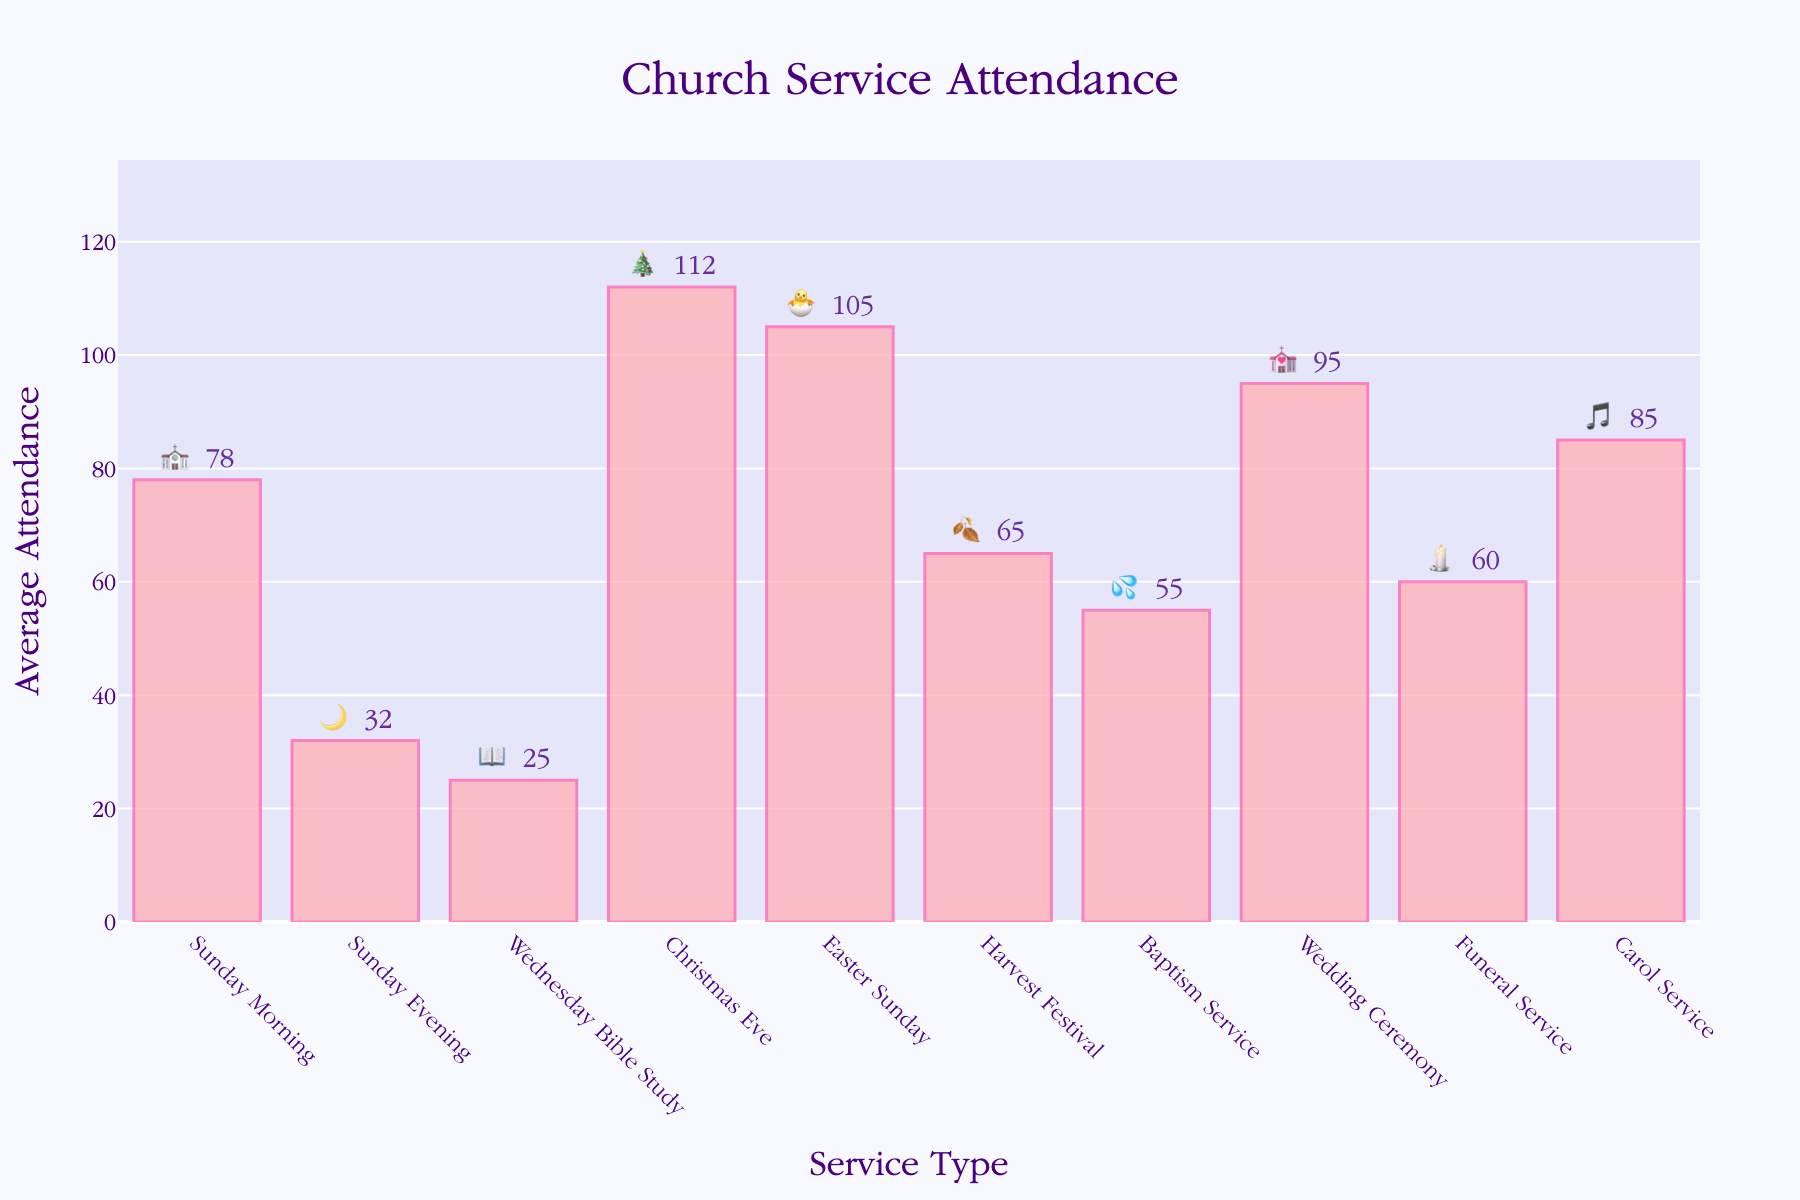What's the title of the figure? The title of the figure is written at the top center of the chart and is usually in a larger font size than other text.
Answer: Church Service Attendance Which service had the highest average attendance? The bar with the highest length represents the service with the highest average attendance.
Answer: Christmas Eve 🎄 What is the average attendance for Sunday Morning services? The vertical length of the bar labeled 'Sunday Morning' on the x-axis will show its average attendance, usually written just above the bar.
Answer: 78 Which service had lower average attendance, Funerals 🕯️ or Baptisms 💦? Compare the heights of the bars for 'Funeral Service' and 'Baptism Service'; the shorter bar indicates lower attendance.
Answer: Funerals 🕯️ How much higher is the average attendance for the Carol Service 🎵 than the Wednesday Bible Study 📖? Subtract the average attendance of the Wednesday Bible Study from the average attendance of the Carol Service using their respective bar heights.
Answer: 60 (85 - 25) What is the combined average attendance for Easter Sunday 🐣 and Wedding Ceremonies 💒? Add the average attendance of Easter Sunday and Wedding Ceremonies as given by the heights of their respective bars.
Answer: 200 (105 + 95) Which service type has approximately twice the average attendance of the Wednesday Bible Study 📖? Find a bar whose height is approximately double that of the Wednesday Bible Study bar height.
Answer: Sunday Evening 🌙 (32 is close to 2*25) Which service categories have an average attendance between 50 and 70? Identify the bars with heights within the 50 to 70 range.
Answer: Harvest Festival 🍂 and Baptism Service 💦 How does the average attendance of the Sunday Morning ⛪ compare to the Easter Sunday 🐣 service? Compare the heights of the bars for Sunday Morning and Easter Sunday; note which is taller.
Answer: Easter Sunday 🐣 has higher attendance If the Harvest Festival 🍂 and Carol Service 🎵 had a combined event, what would their total attendance be? Add the average attendance of the Harvest Festival and Carol Service; the answer is the sum of their heights.
Answer: 150 (65 + 85) 